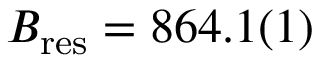<formula> <loc_0><loc_0><loc_500><loc_500>B _ { r e s } = 8 6 4 . 1 ( 1 )</formula> 